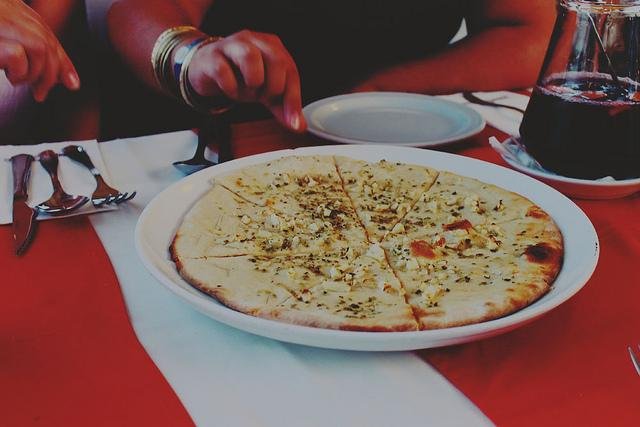What Leavening was used in this dish? yeast 